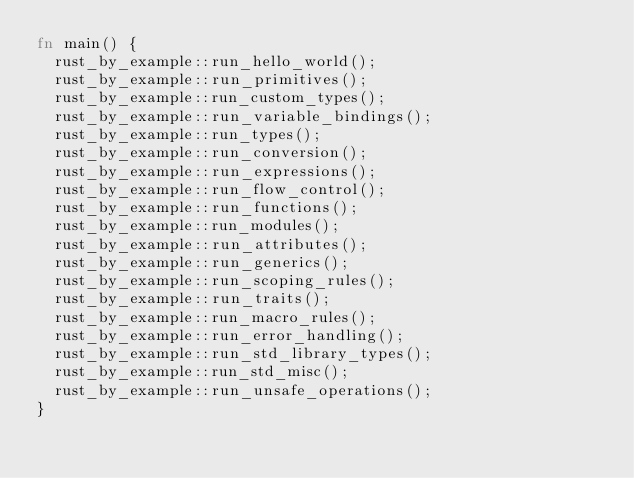Convert code to text. <code><loc_0><loc_0><loc_500><loc_500><_Rust_>fn main() {
  rust_by_example::run_hello_world();
  rust_by_example::run_primitives();
  rust_by_example::run_custom_types();
  rust_by_example::run_variable_bindings();
  rust_by_example::run_types();
  rust_by_example::run_conversion();
  rust_by_example::run_expressions();
  rust_by_example::run_flow_control();
  rust_by_example::run_functions();
  rust_by_example::run_modules();
  rust_by_example::run_attributes();
  rust_by_example::run_generics();
  rust_by_example::run_scoping_rules();
  rust_by_example::run_traits();
  rust_by_example::run_macro_rules();
  rust_by_example::run_error_handling();
  rust_by_example::run_std_library_types();
  rust_by_example::run_std_misc();
  rust_by_example::run_unsafe_operations();
}
</code> 